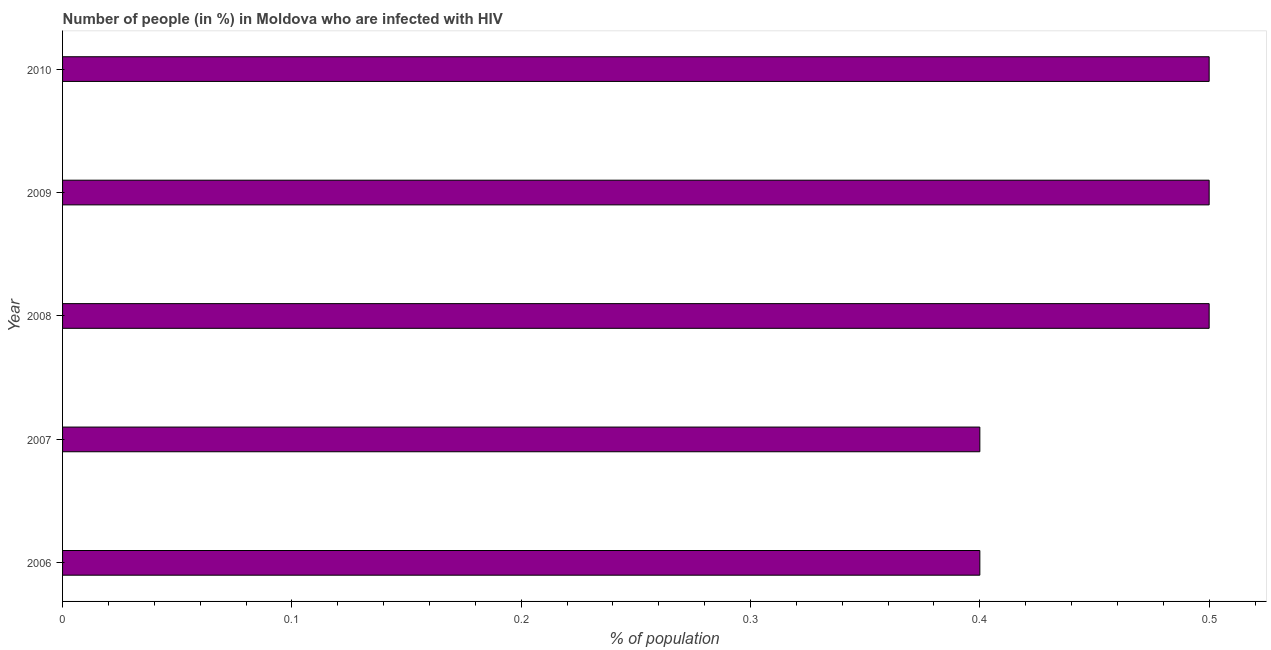Does the graph contain any zero values?
Make the answer very short. No. Does the graph contain grids?
Provide a short and direct response. No. What is the title of the graph?
Ensure brevity in your answer.  Number of people (in %) in Moldova who are infected with HIV. What is the label or title of the X-axis?
Your answer should be very brief. % of population. What is the label or title of the Y-axis?
Make the answer very short. Year. What is the number of people infected with hiv in 2006?
Offer a terse response. 0.4. What is the sum of the number of people infected with hiv?
Provide a succinct answer. 2.3. What is the difference between the number of people infected with hiv in 2009 and 2010?
Offer a very short reply. 0. What is the average number of people infected with hiv per year?
Provide a succinct answer. 0.46. What is the median number of people infected with hiv?
Provide a succinct answer. 0.5. Do a majority of the years between 2009 and 2010 (inclusive) have number of people infected with hiv greater than 0.02 %?
Ensure brevity in your answer.  Yes. Is the sum of the number of people infected with hiv in 2009 and 2010 greater than the maximum number of people infected with hiv across all years?
Give a very brief answer. Yes. What is the difference between the highest and the lowest number of people infected with hiv?
Your answer should be compact. 0.1. In how many years, is the number of people infected with hiv greater than the average number of people infected with hiv taken over all years?
Provide a succinct answer. 3. How many bars are there?
Give a very brief answer. 5. How many years are there in the graph?
Offer a very short reply. 5. What is the difference between two consecutive major ticks on the X-axis?
Provide a succinct answer. 0.1. Are the values on the major ticks of X-axis written in scientific E-notation?
Your answer should be very brief. No. What is the % of population in 2006?
Give a very brief answer. 0.4. What is the % of population of 2007?
Your answer should be very brief. 0.4. What is the % of population in 2009?
Provide a short and direct response. 0.5. What is the % of population of 2010?
Give a very brief answer. 0.5. What is the difference between the % of population in 2006 and 2007?
Make the answer very short. 0. What is the difference between the % of population in 2006 and 2008?
Your answer should be very brief. -0.1. What is the difference between the % of population in 2006 and 2010?
Keep it short and to the point. -0.1. What is the difference between the % of population in 2007 and 2009?
Make the answer very short. -0.1. What is the difference between the % of population in 2007 and 2010?
Provide a succinct answer. -0.1. What is the difference between the % of population in 2008 and 2009?
Offer a terse response. 0. What is the difference between the % of population in 2009 and 2010?
Give a very brief answer. 0. What is the ratio of the % of population in 2006 to that in 2007?
Give a very brief answer. 1. What is the ratio of the % of population in 2006 to that in 2009?
Your response must be concise. 0.8. What is the ratio of the % of population in 2007 to that in 2009?
Your answer should be compact. 0.8. What is the ratio of the % of population in 2007 to that in 2010?
Keep it short and to the point. 0.8. What is the ratio of the % of population in 2008 to that in 2009?
Keep it short and to the point. 1. 